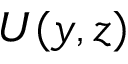Convert formula to latex. <formula><loc_0><loc_0><loc_500><loc_500>{ U } ( y , z )</formula> 